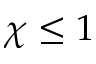<formula> <loc_0><loc_0><loc_500><loc_500>\chi \leq 1</formula> 